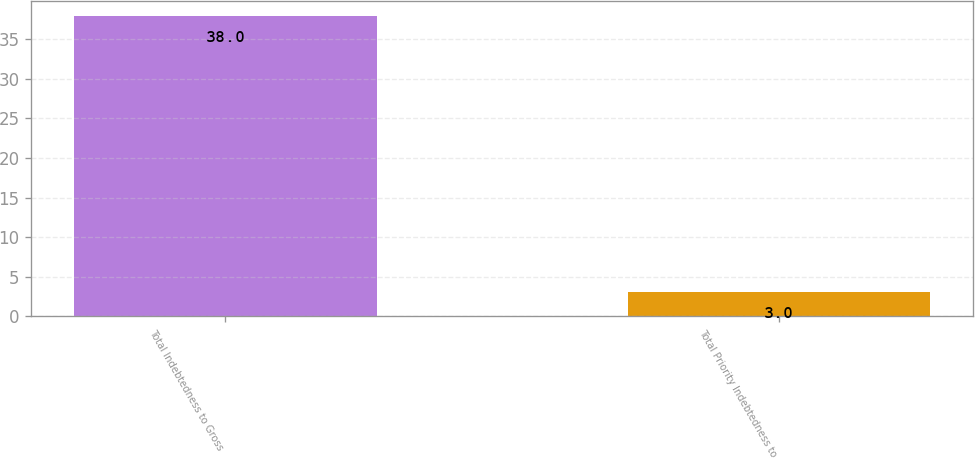Convert chart. <chart><loc_0><loc_0><loc_500><loc_500><bar_chart><fcel>Total Indebtedness to Gross<fcel>Total Priority Indebtedness to<nl><fcel>38<fcel>3<nl></chart> 